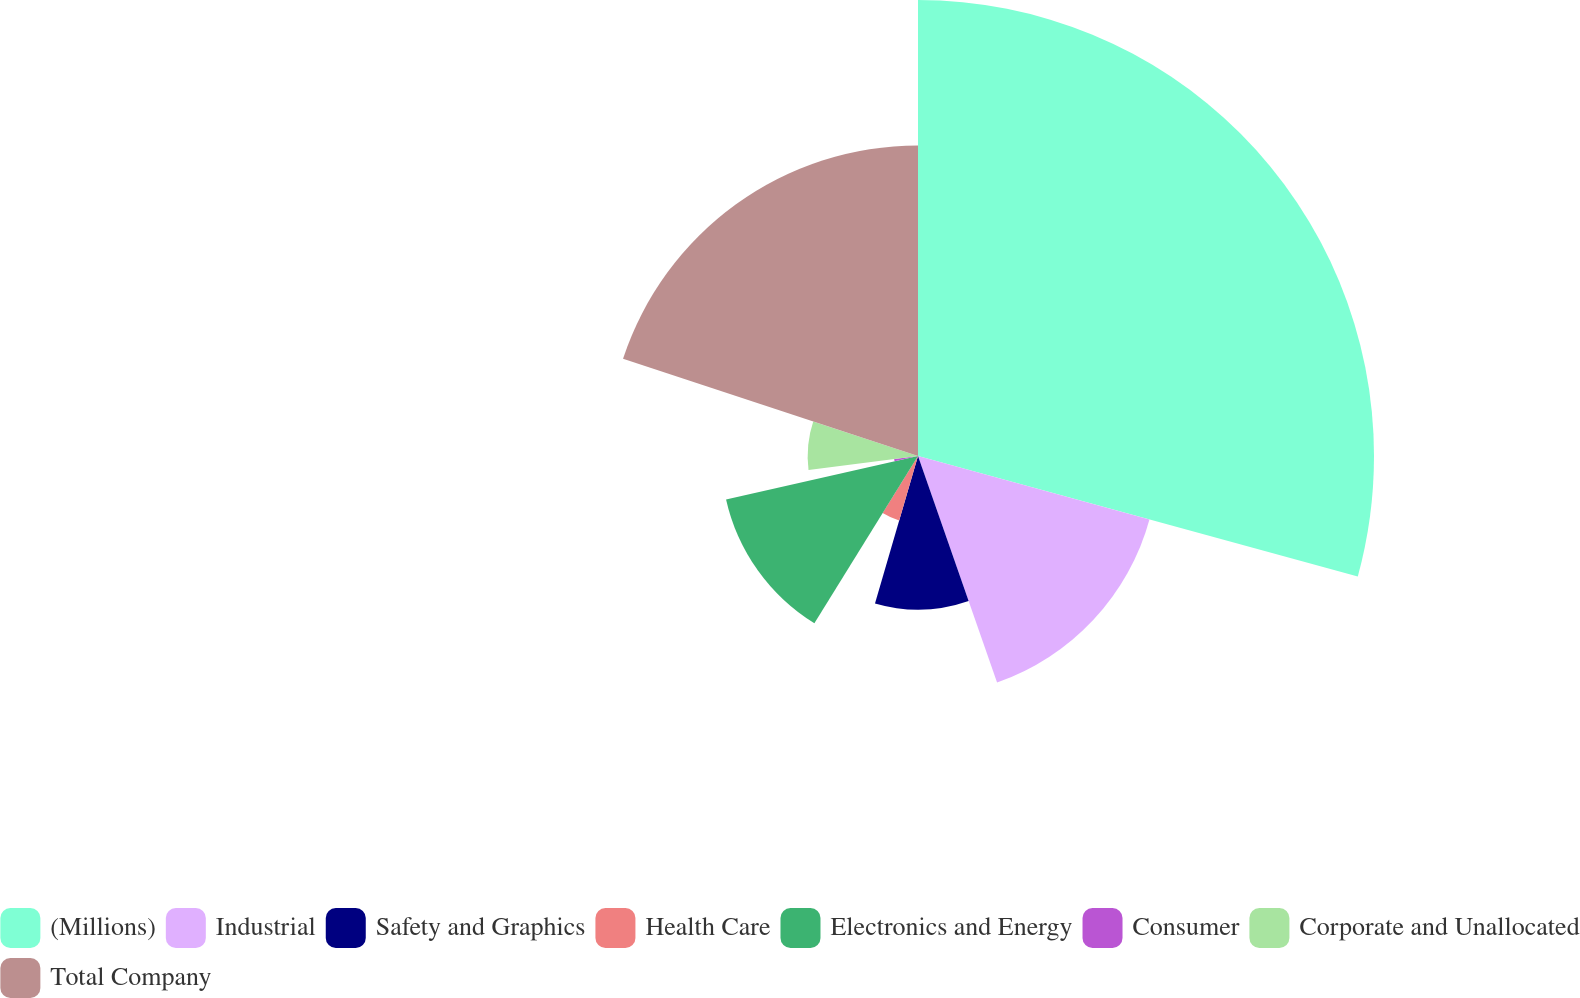<chart> <loc_0><loc_0><loc_500><loc_500><pie_chart><fcel>(Millions)<fcel>Industrial<fcel>Safety and Graphics<fcel>Health Care<fcel>Electronics and Energy<fcel>Consumer<fcel>Corporate and Unallocated<fcel>Total Company<nl><fcel>29.26%<fcel>15.4%<fcel>9.86%<fcel>4.31%<fcel>12.63%<fcel>1.54%<fcel>7.08%<fcel>19.93%<nl></chart> 